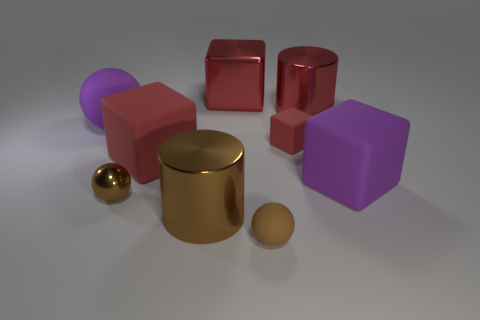There is a metallic sphere; does it have the same color as the metal cylinder that is in front of the large red rubber thing?
Your response must be concise. Yes. There is a matte object that is the same color as the small matte block; what shape is it?
Your answer should be very brief. Cube. Are there any cylinders of the same color as the small shiny object?
Offer a terse response. Yes. Is the large brown thing made of the same material as the small red object?
Give a very brief answer. No. Is the large shiny block the same color as the tiny cube?
Ensure brevity in your answer.  Yes. There is another object that is the same shape as the big brown object; what color is it?
Your answer should be compact. Red. Does the brown sphere on the left side of the brown matte thing have the same size as the big matte ball?
Offer a very short reply. No. Is the number of metal objects that are behind the tiny rubber block less than the number of red objects?
Make the answer very short. Yes. There is a metallic cylinder in front of the purple matte thing left of the large brown metal cylinder; how big is it?
Provide a short and direct response. Large. Is the number of red cylinders less than the number of big rubber things?
Give a very brief answer. Yes. 